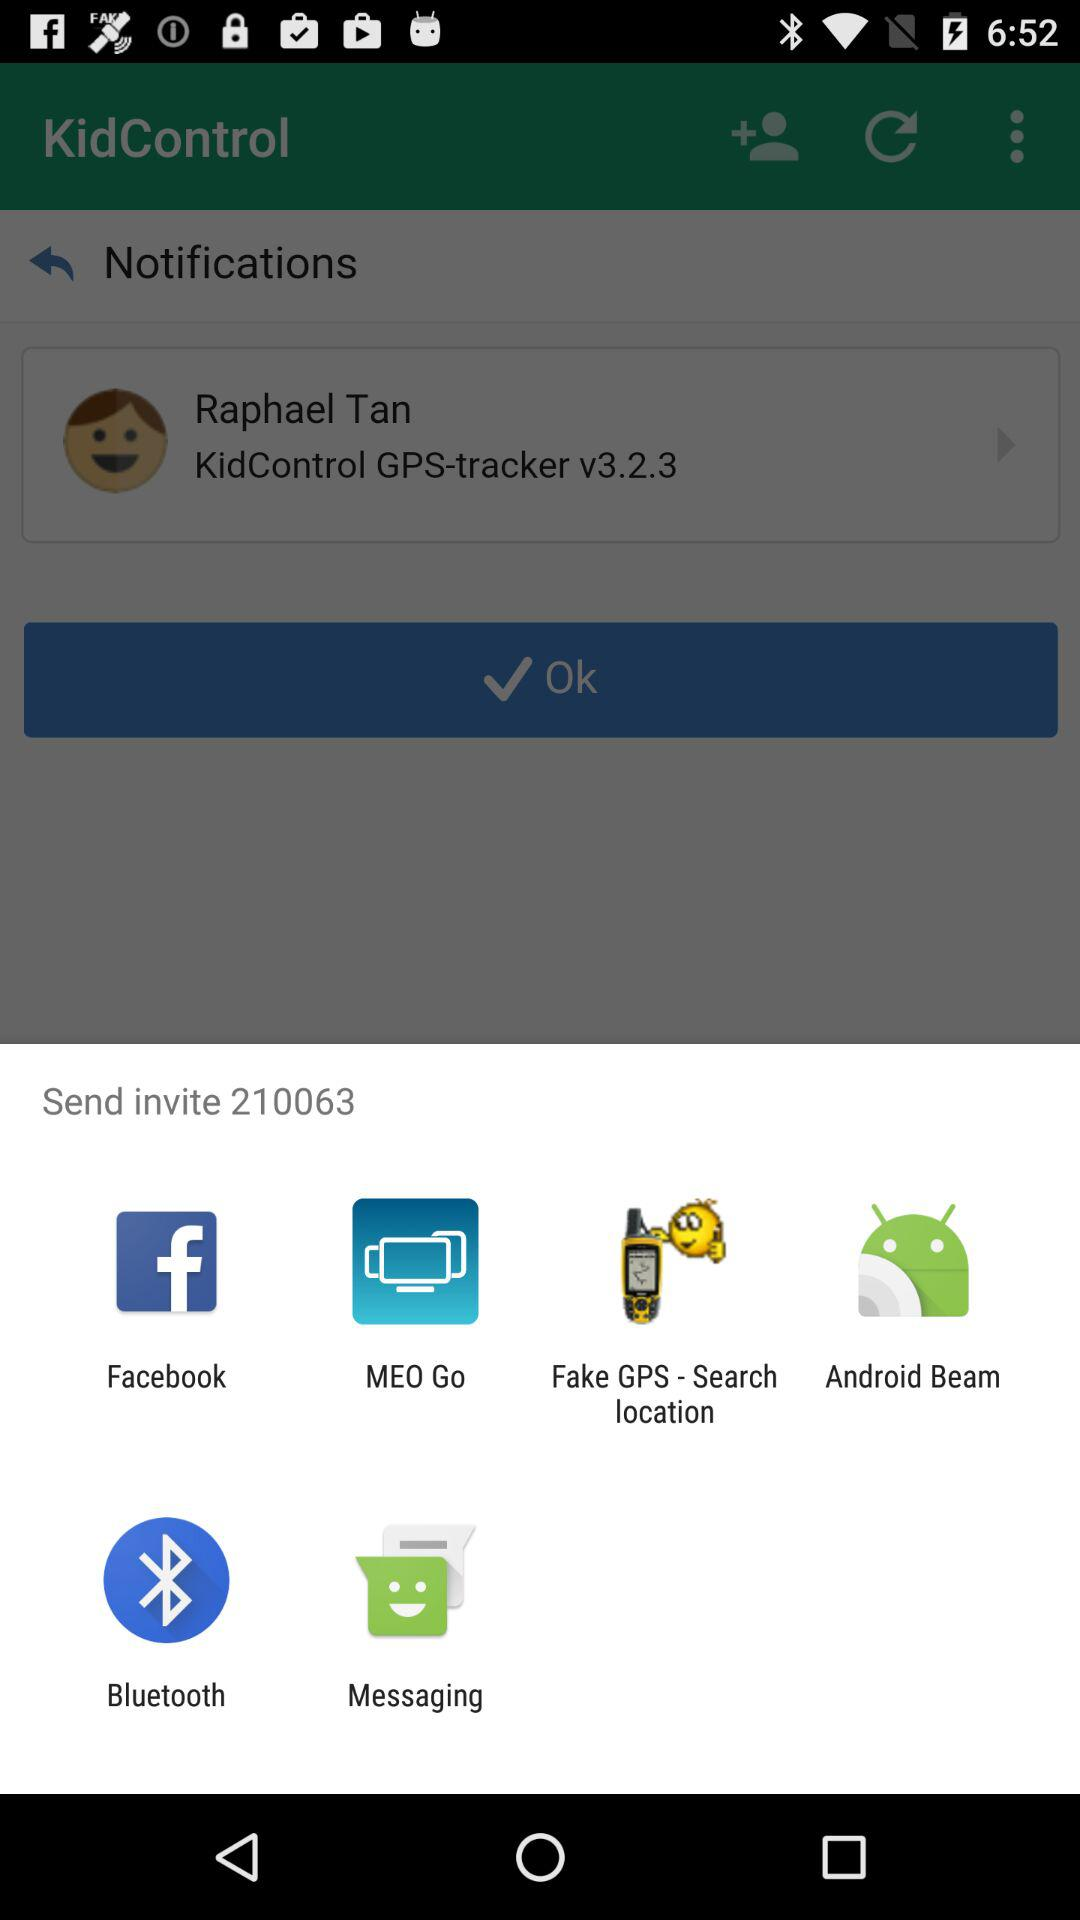What app is available to share an invite? You can share an invite with "Facebook", "MEO Go", "Fake GPS - Search location", "Android Beam", "Bluetooth" and "Messaging". 